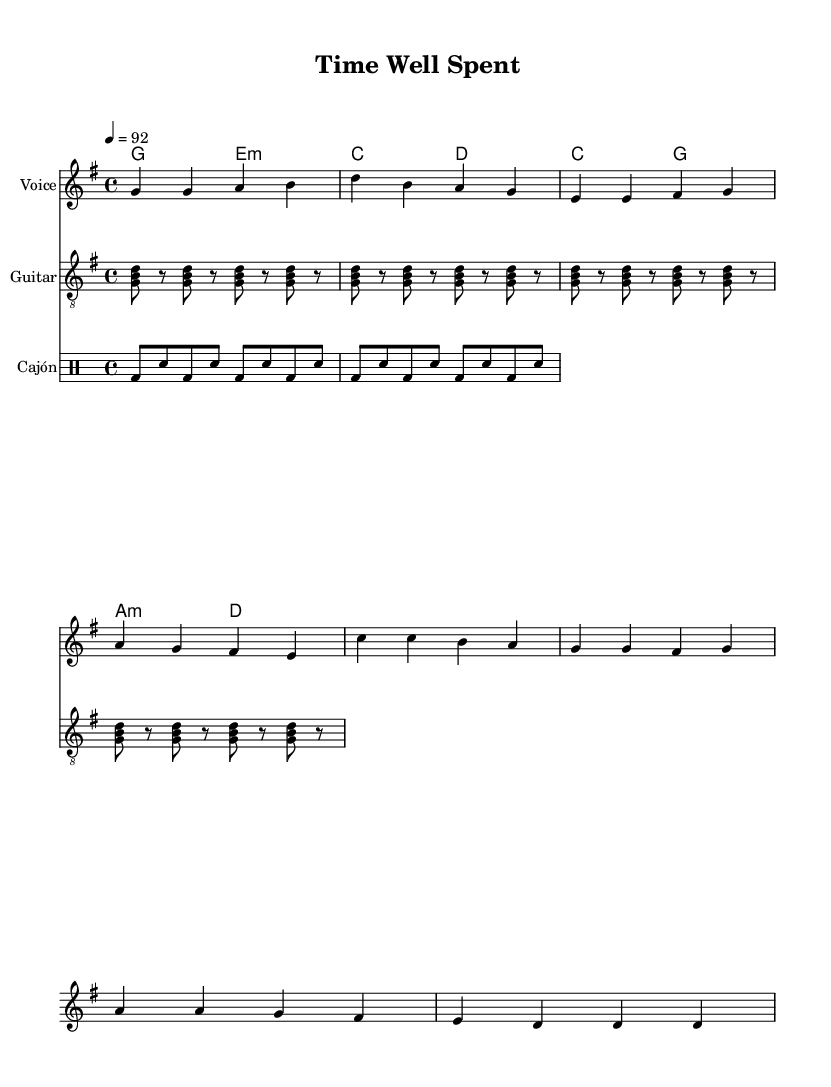What is the key signature of this music? The key signature is indicated at the beginning of the score. In this case, it shows one sharp, which corresponds to G major.
Answer: G major What is the time signature of this piece? The time signature is found at the beginning of the score, where it indicates the number of beats in a measure. Here, it is 4 over 4, meaning there are four beats per measure.
Answer: 4/4 What is the tempo marking for this composition? The tempo marking is specified in beats per minute at the beginning of the score. It indicates that the piece should be played at 92 beats per minute.
Answer: 92 How many measures are in the verse section? To find the number of measures in the verse section, one can count the groupings of notes and rests in the melody and verify against the chord changes. The verse section has 4 measures.
Answer: 4 What chords are used in the chorus? The chords can be identified in the chord mode section of the score. The chorus includes C major and A minor, followed by D major.
Answer: C, A minor, D What is the lyrical theme of the song? The lyrics convey a theme of reflection on time and priorities. The verses discuss the costs of chasing dreams, while the chorus emphasizes living for today and planning for tomorrow.
Answer: Work-life balance What type of drum is featured in the score? The drum staff specifies the instrumentation at the beginning, and it shows a cajón. This is a percussion instrument commonly used in acoustic rock genres.
Answer: Cajón 